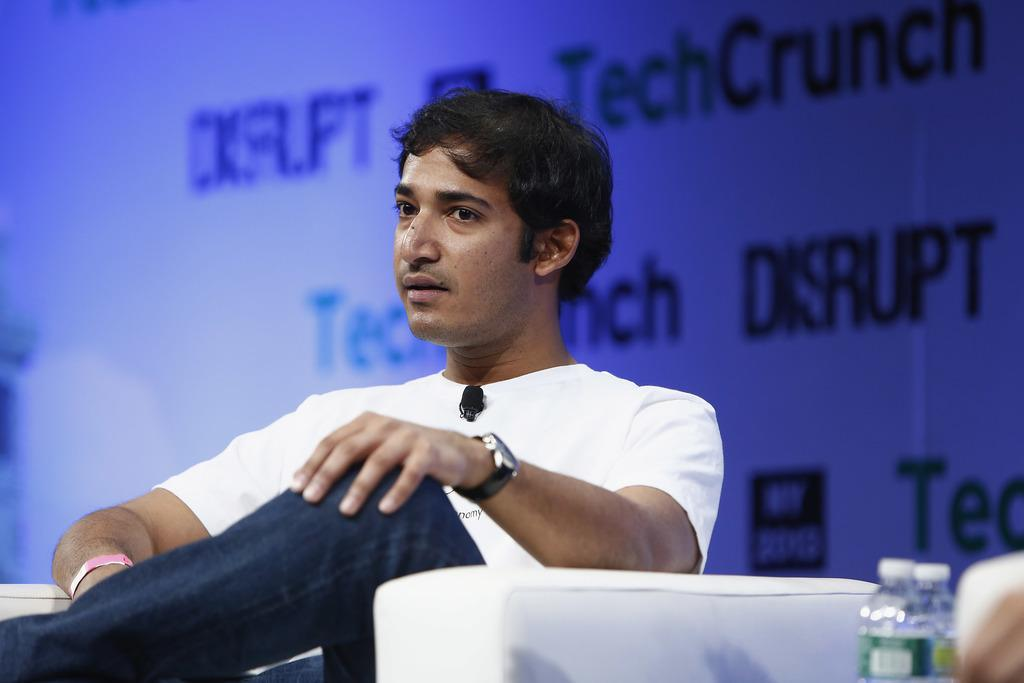What is the man doing in the image? There is a man sitting on a chair in the image. Can you describe any accessories the man is wearing? The man has a watch on his hand. What objects can be seen in the image besides the man? There are bottles placed in the image. What is the purpose of the banner visible in the image? There is a banner visible in the image with something written on it, but we cannot determine its purpose without knowing what is written on it. What type of metal is the maid using to weigh items on the scale in the image? There is no maid, metal, or scale present in the image. 